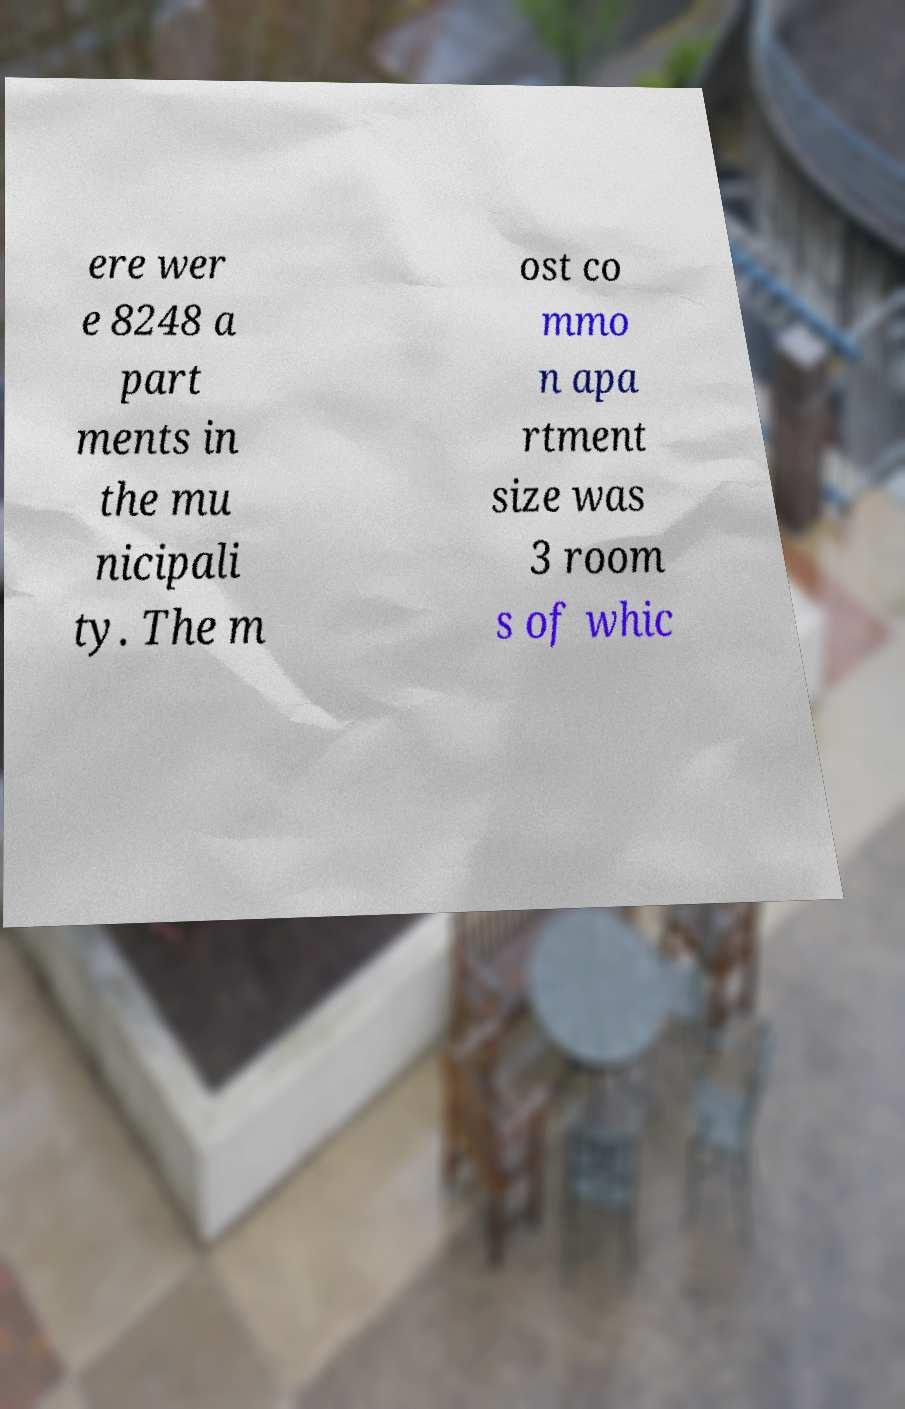Could you assist in decoding the text presented in this image and type it out clearly? ere wer e 8248 a part ments in the mu nicipali ty. The m ost co mmo n apa rtment size was 3 room s of whic 